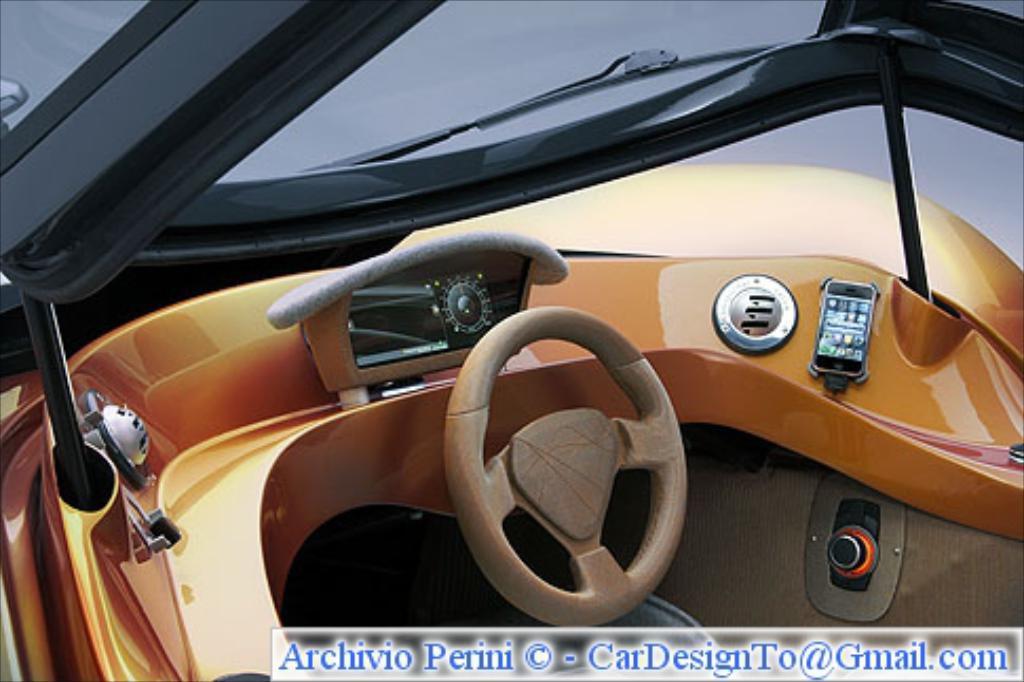In one or two sentences, can you explain what this image depicts? In this image this is a view from the car as we can see there is a steering in middle of this image and there is some text written in the bottom of this image. 